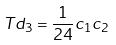Convert formula to latex. <formula><loc_0><loc_0><loc_500><loc_500>T d _ { 3 } = \frac { 1 } { 2 4 } c _ { 1 } c _ { 2 }</formula> 